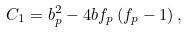<formula> <loc_0><loc_0><loc_500><loc_500>C _ { 1 } = b _ { p } ^ { 2 } - 4 b f _ { p } \left ( f _ { p } - 1 \right ) ,</formula> 